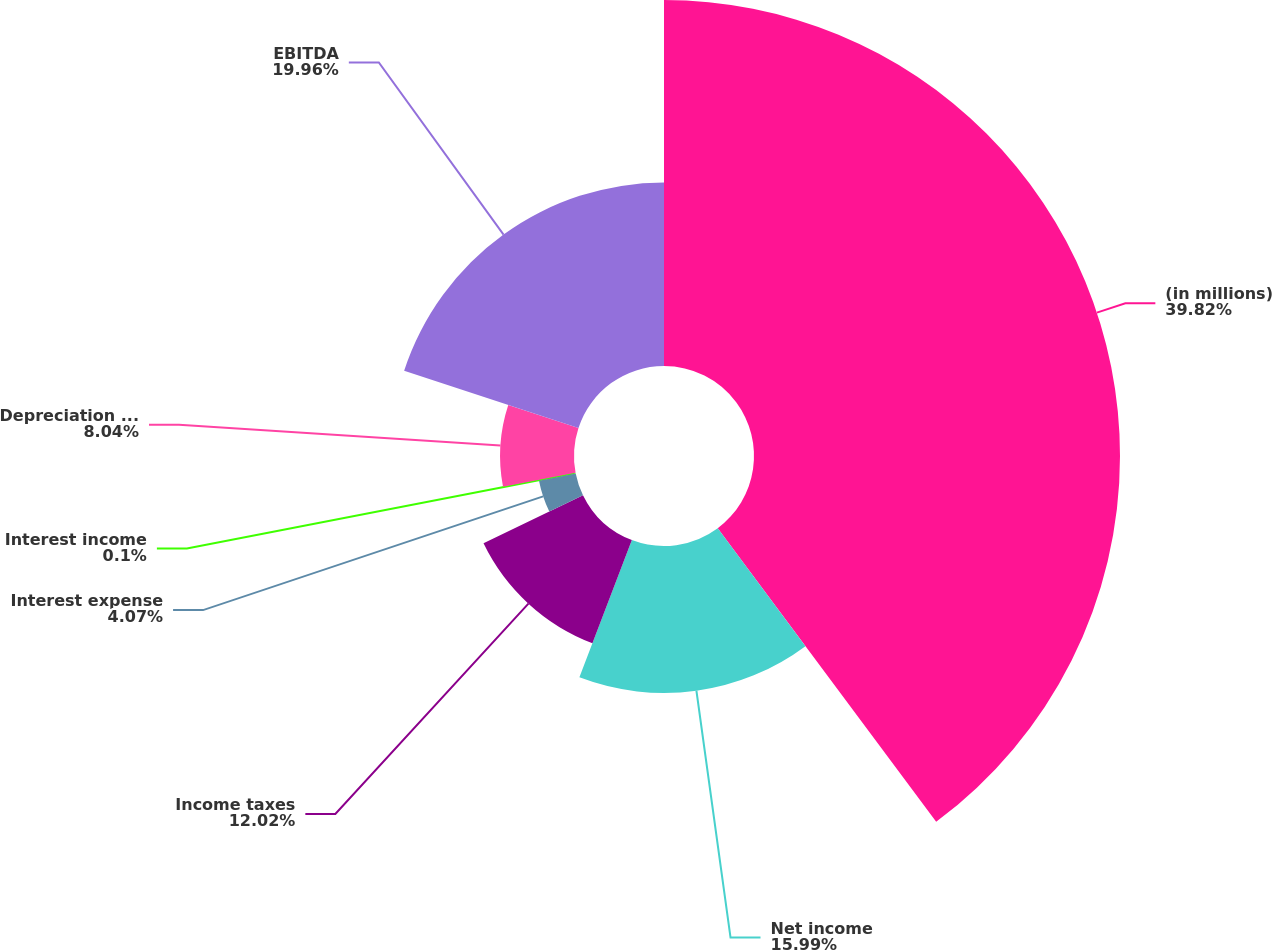Convert chart to OTSL. <chart><loc_0><loc_0><loc_500><loc_500><pie_chart><fcel>(in millions)<fcel>Net income<fcel>Income taxes<fcel>Interest expense<fcel>Interest income<fcel>Depreciation and amortization<fcel>EBITDA<nl><fcel>39.82%<fcel>15.99%<fcel>12.02%<fcel>4.07%<fcel>0.1%<fcel>8.04%<fcel>19.96%<nl></chart> 